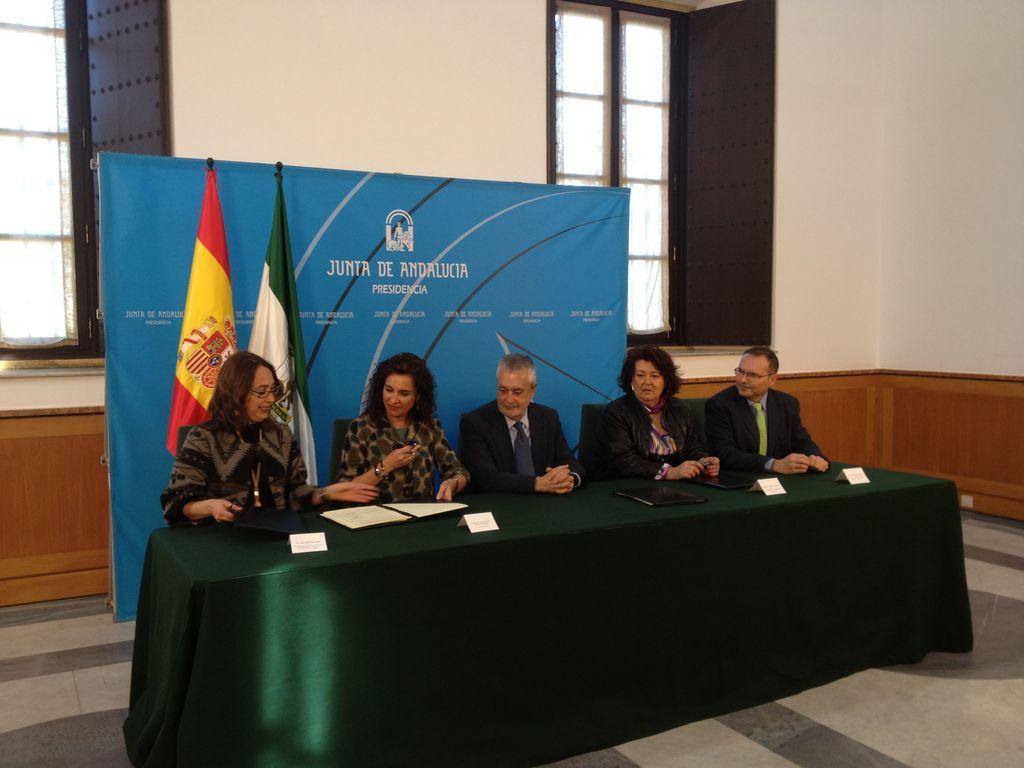Please provide a concise description of this image. In this image we can see a five persons sitting on a chair. Here we can see these two women are having a conversation. This is a table where a file and name plates are kept on it. In the background we can see a hoarding and two flags. Here we can see a glass window. 